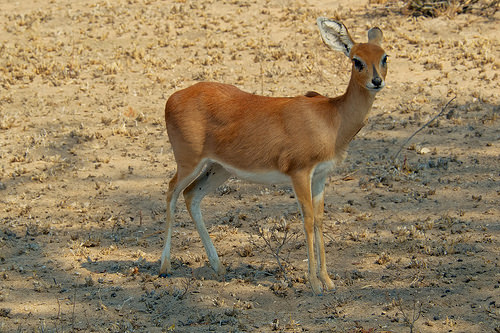<image>
Can you confirm if the deer is next to the sand? No. The deer is not positioned next to the sand. They are located in different areas of the scene. 